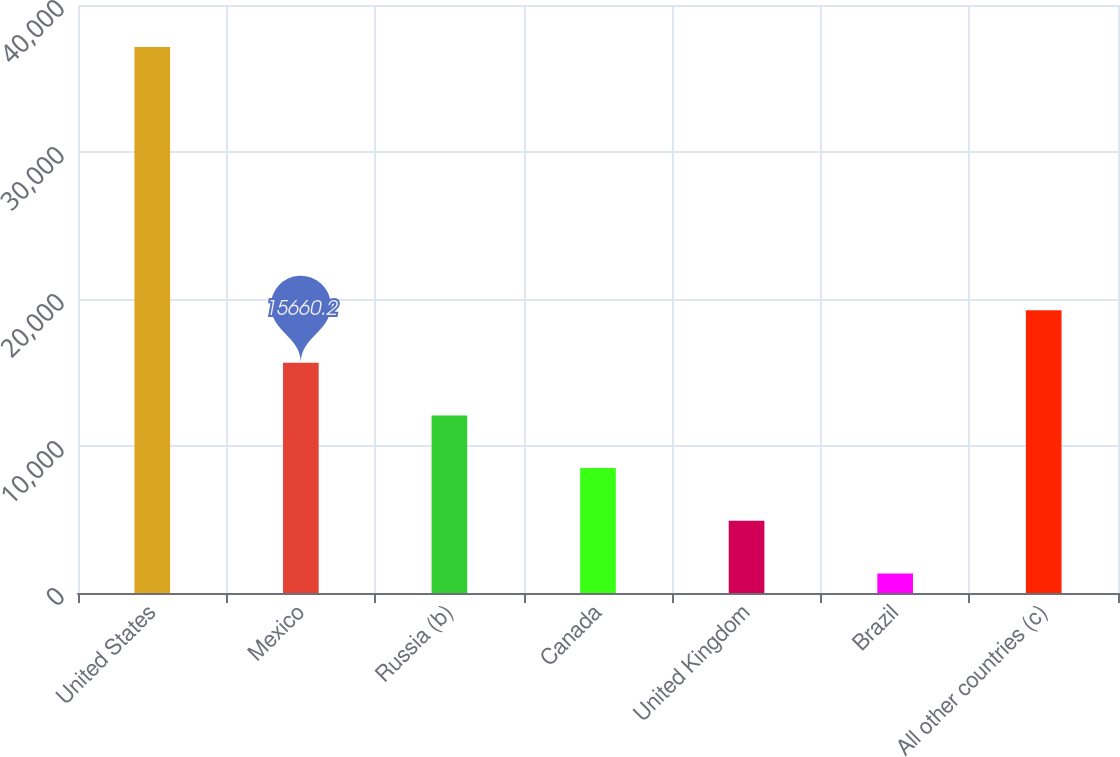Convert chart. <chart><loc_0><loc_0><loc_500><loc_500><bar_chart><fcel>United States<fcel>Mexico<fcel>Russia (b)<fcel>Canada<fcel>United Kingdom<fcel>Brazil<fcel>All other countries (c)<nl><fcel>37148<fcel>15660.2<fcel>12078.9<fcel>8497.6<fcel>4916.3<fcel>1335<fcel>19241.5<nl></chart> 